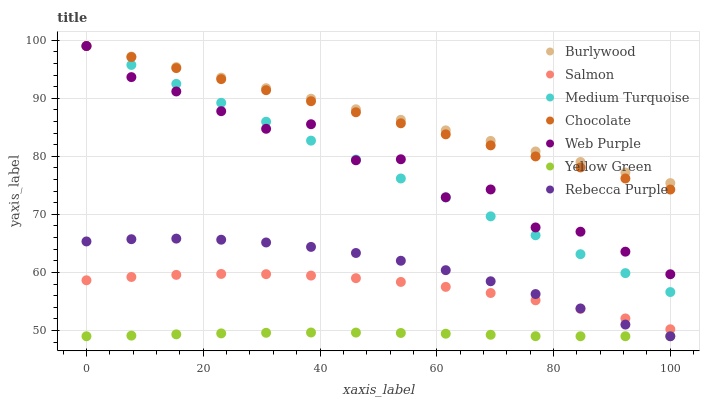Does Yellow Green have the minimum area under the curve?
Answer yes or no. Yes. Does Burlywood have the maximum area under the curve?
Answer yes or no. Yes. Does Salmon have the minimum area under the curve?
Answer yes or no. No. Does Salmon have the maximum area under the curve?
Answer yes or no. No. Is Chocolate the smoothest?
Answer yes or no. Yes. Is Web Purple the roughest?
Answer yes or no. Yes. Is Burlywood the smoothest?
Answer yes or no. No. Is Burlywood the roughest?
Answer yes or no. No. Does Yellow Green have the lowest value?
Answer yes or no. Yes. Does Salmon have the lowest value?
Answer yes or no. No. Does Medium Turquoise have the highest value?
Answer yes or no. Yes. Does Salmon have the highest value?
Answer yes or no. No. Is Yellow Green less than Medium Turquoise?
Answer yes or no. Yes. Is Burlywood greater than Rebecca Purple?
Answer yes or no. Yes. Does Medium Turquoise intersect Web Purple?
Answer yes or no. Yes. Is Medium Turquoise less than Web Purple?
Answer yes or no. No. Is Medium Turquoise greater than Web Purple?
Answer yes or no. No. Does Yellow Green intersect Medium Turquoise?
Answer yes or no. No. 